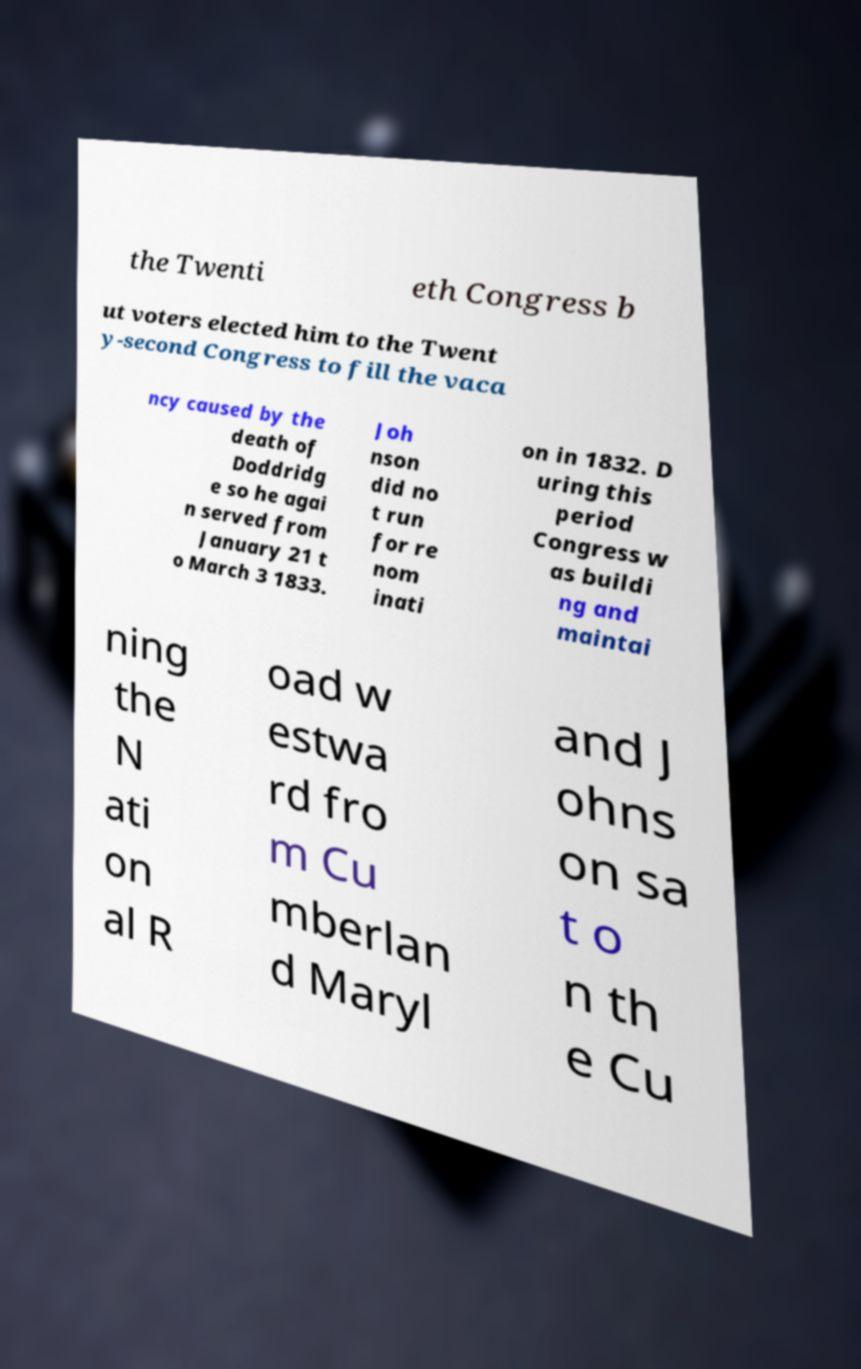For documentation purposes, I need the text within this image transcribed. Could you provide that? the Twenti eth Congress b ut voters elected him to the Twent y-second Congress to fill the vaca ncy caused by the death of Doddridg e so he agai n served from January 21 t o March 3 1833. Joh nson did no t run for re nom inati on in 1832. D uring this period Congress w as buildi ng and maintai ning the N ati on al R oad w estwa rd fro m Cu mberlan d Maryl and J ohns on sa t o n th e Cu 